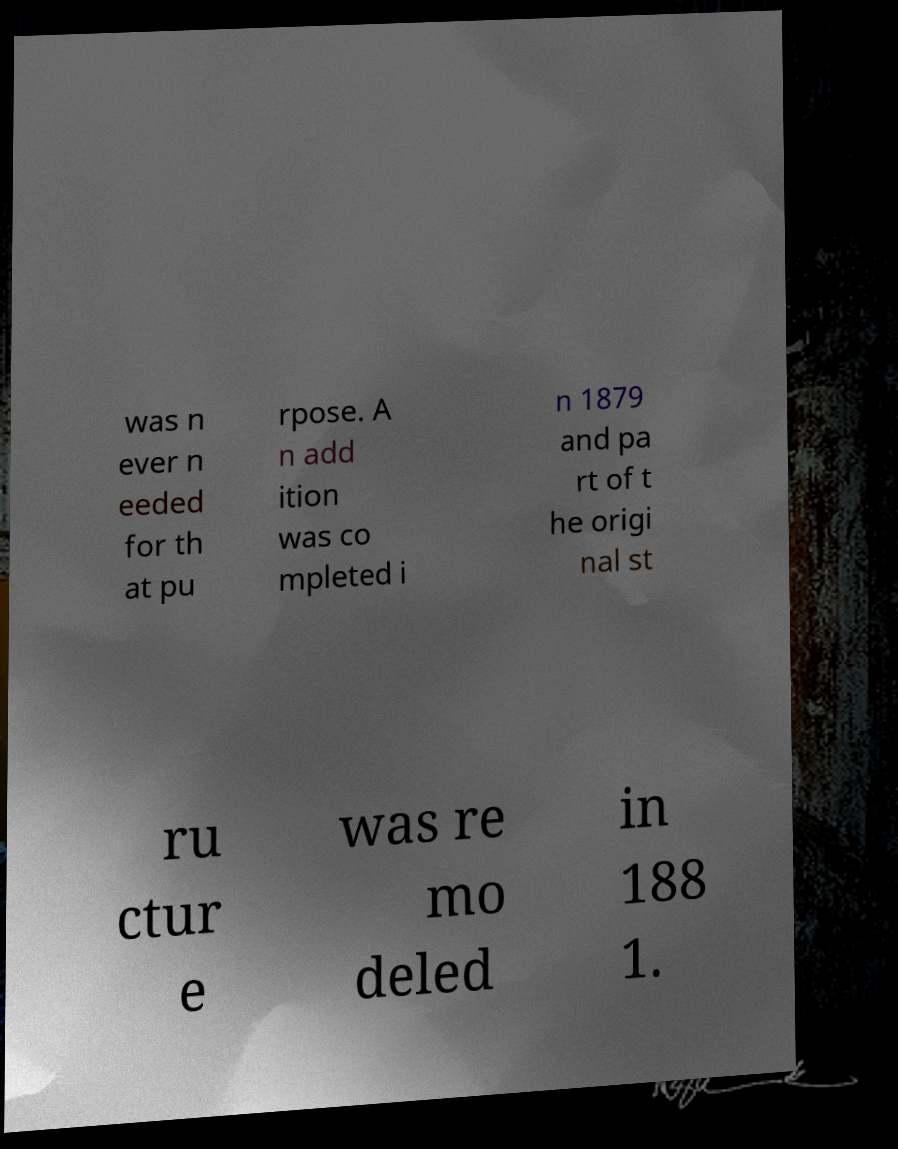Can you accurately transcribe the text from the provided image for me? was n ever n eeded for th at pu rpose. A n add ition was co mpleted i n 1879 and pa rt of t he origi nal st ru ctur e was re mo deled in 188 1. 